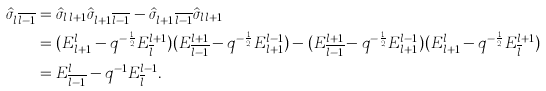<formula> <loc_0><loc_0><loc_500><loc_500>\hat { \sigma } _ { l \, \overline { l - 1 } } & = \hat { \sigma } _ { l \, l + 1 } \hat { \sigma } _ { l + 1 \, \overline { l - 1 } } - \hat { \sigma } _ { l + 1 \, \overline { l - 1 } } \hat { \sigma } _ { l \, l + 1 } \\ & = ( E ^ { l } _ { l + 1 } - q ^ { - \frac { 1 } { 2 } } E ^ { l + 1 } _ { \overline { l } } ) ( E ^ { l + 1 } _ { \overline { l - 1 } } - q ^ { - \frac { 1 } { 2 } } E ^ { l - 1 } _ { l + 1 } ) - ( E ^ { l + 1 } _ { \overline { l - 1 } } - q ^ { - \frac { 1 } { 2 } } E ^ { l - 1 } _ { l + 1 } ) ( E ^ { l } _ { l + 1 } - q ^ { - \frac { 1 } { 2 } } E ^ { l + 1 } _ { \overline { l } } ) \\ & = E ^ { l } _ { \overline { l - 1 } } - q ^ { - 1 } E ^ { l - 1 } _ { \overline { l } } .</formula> 